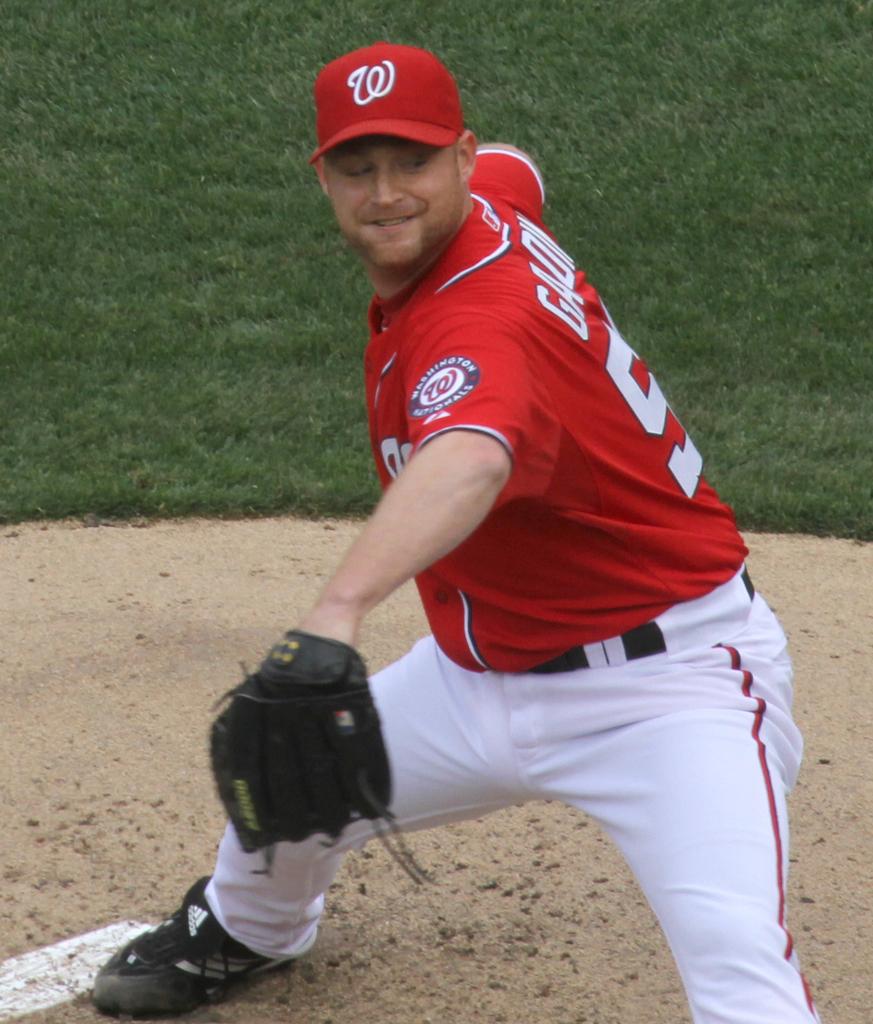What brand of shoes is he wearing?
Your answer should be compact. Adidas. 